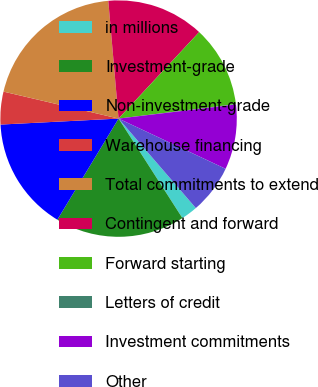Convert chart to OTSL. <chart><loc_0><loc_0><loc_500><loc_500><pie_chart><fcel>in millions<fcel>Investment-grade<fcel>Non-investment-grade<fcel>Warehouse financing<fcel>Total commitments to extend<fcel>Contingent and forward<fcel>Forward starting<fcel>Letters of credit<fcel>Investment commitments<fcel>Other<nl><fcel>2.26%<fcel>17.74%<fcel>15.53%<fcel>4.47%<fcel>19.95%<fcel>13.32%<fcel>11.11%<fcel>0.05%<fcel>8.89%<fcel>6.68%<nl></chart> 